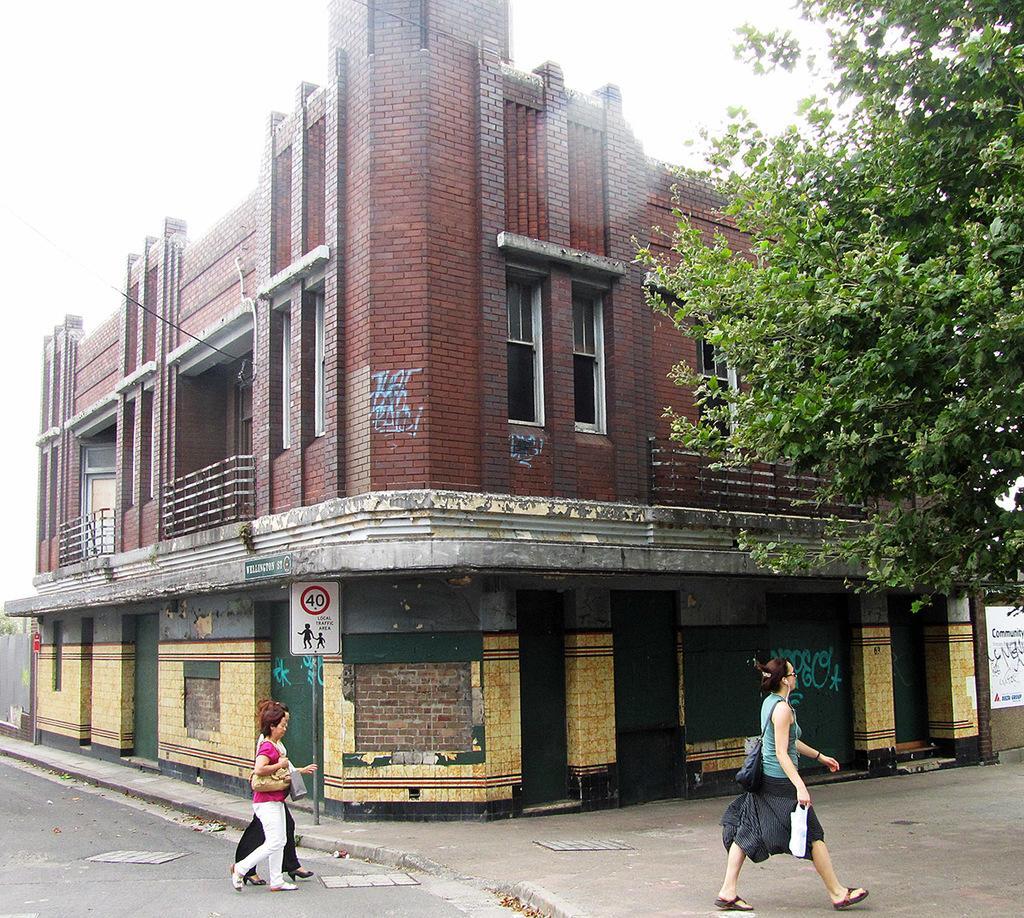How would you summarize this image in a sentence or two? This image consists of buildings. At the bottom, there is a road on which there are three persons walking. To the right, there is a tree. The building is in brown color. 